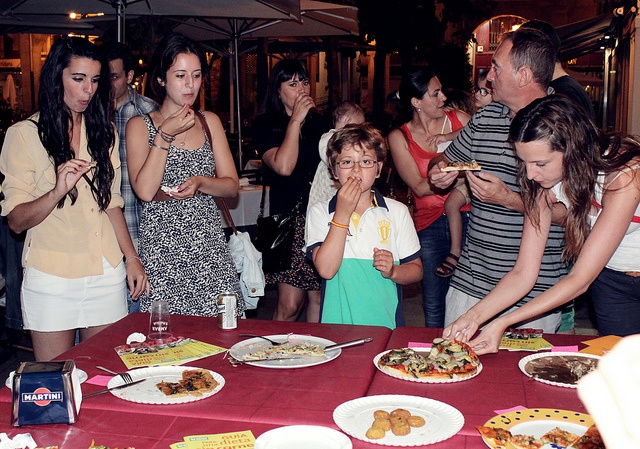Describe the objects in this image and their specific colors. I can see dining table in black, brown, maroon, and lightgray tones, people in black, tan, lightgray, and gray tones, people in black, lightpink, brown, and maroon tones, people in black, darkgray, gray, and brown tones, and people in black, gray, darkgray, and brown tones in this image. 